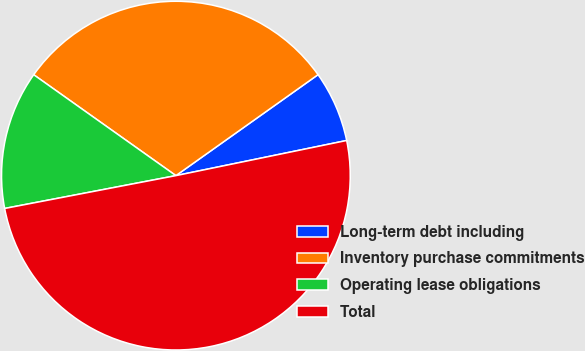Convert chart. <chart><loc_0><loc_0><loc_500><loc_500><pie_chart><fcel>Long-term debt including<fcel>Inventory purchase commitments<fcel>Operating lease obligations<fcel>Total<nl><fcel>6.6%<fcel>30.35%<fcel>12.84%<fcel>50.22%<nl></chart> 